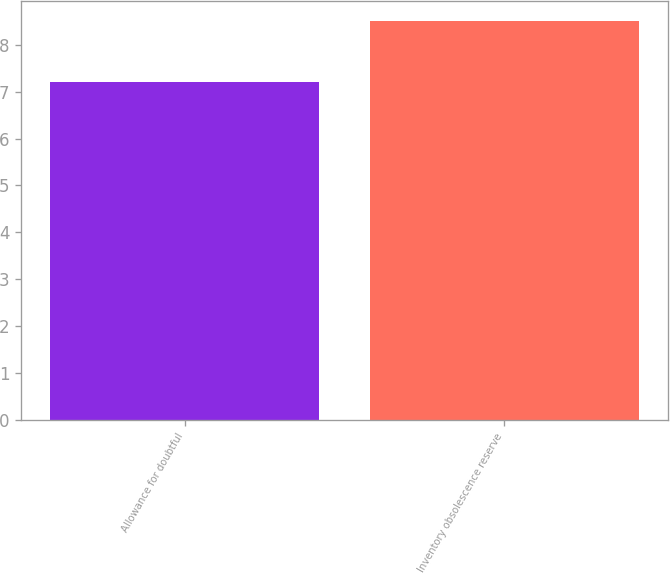Convert chart. <chart><loc_0><loc_0><loc_500><loc_500><bar_chart><fcel>Allowance for doubtful<fcel>Inventory obsolescence reserve<nl><fcel>7.21<fcel>8.52<nl></chart> 